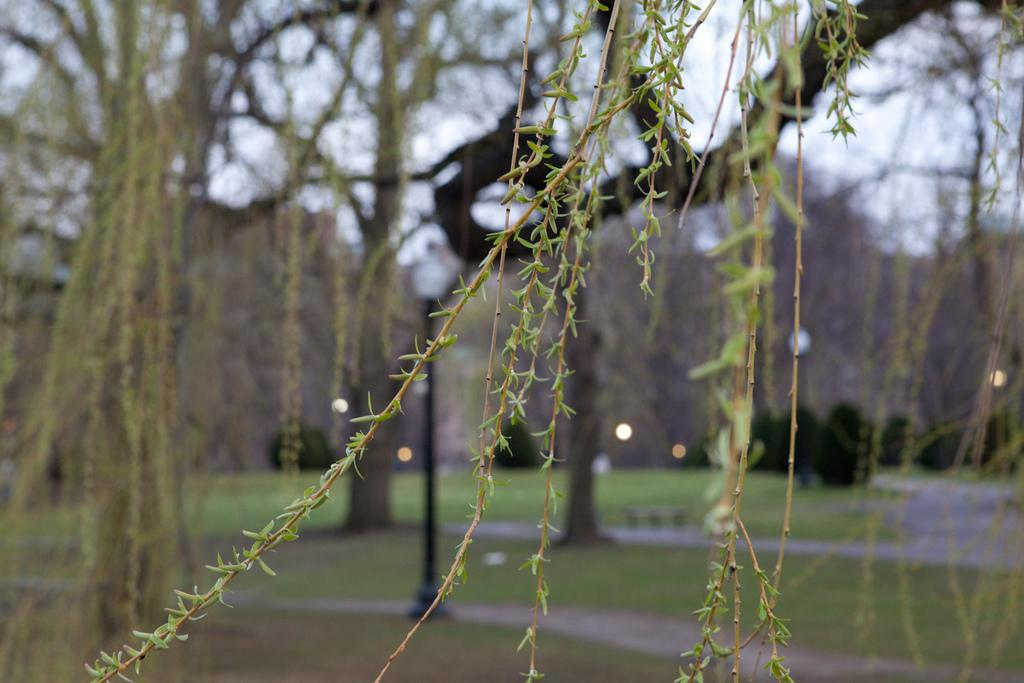What type of vegetation can be seen in the image? There are big trees, plants, and bushes in the image. What can be found on the ground in the image? There is green grass on the ground in the image. What structures are present in the image? There is a pole and a road in the image. What is visible at the top of the image? The sky is visible at the top of the image. What else can be seen in the image? There are lights in the image. How many steps are visible in the image? There are no steps present in the image. What type of string is being used to hold up the bushes in the image? There is no string being used to hold up the bushes in the image; they are naturally growing. 